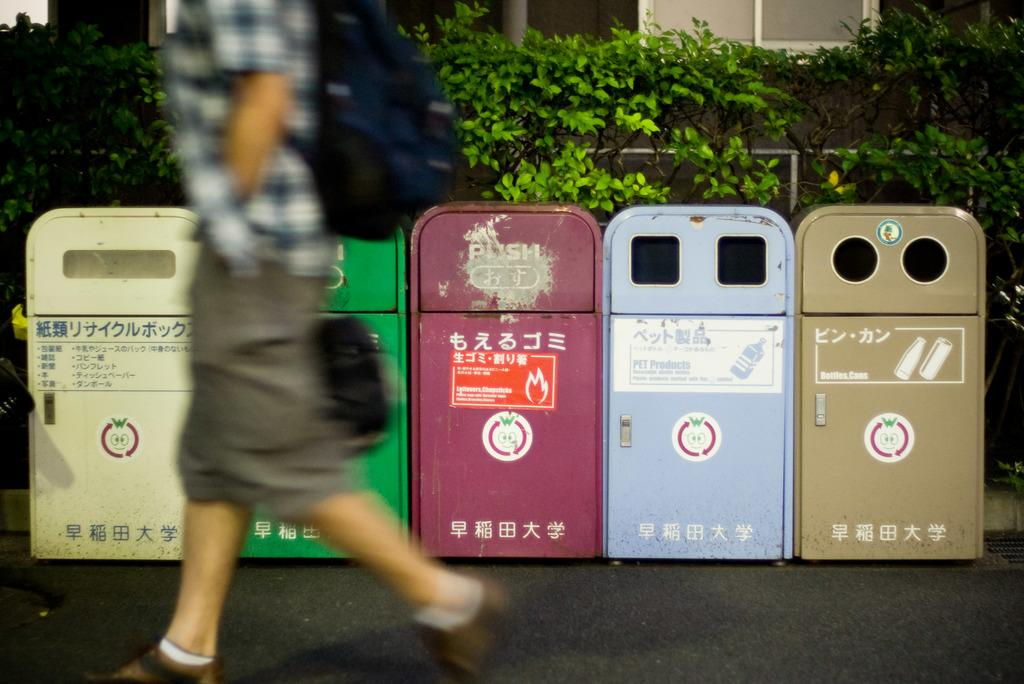Provide a one-sentence caption for the provided image. five separate trash bins with one of them labeled with 'pet products'. 